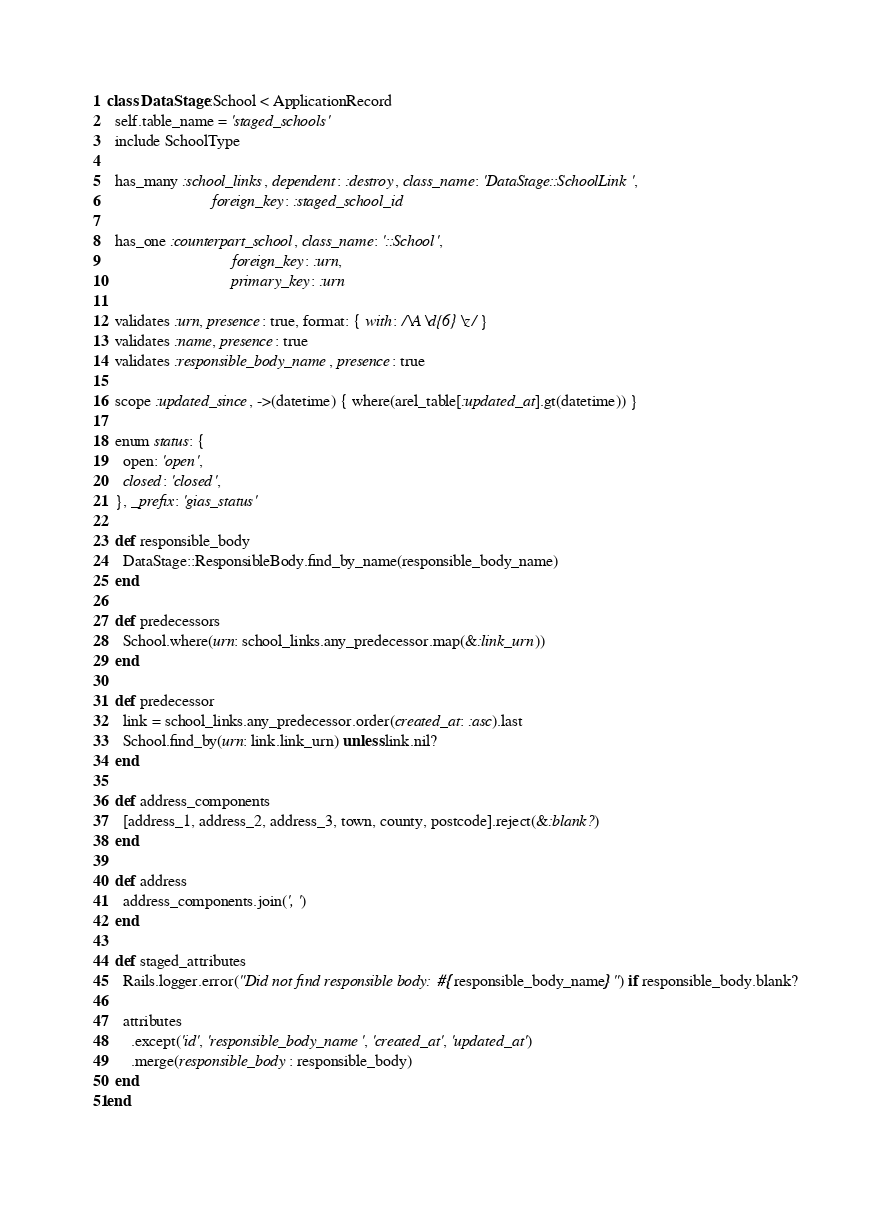<code> <loc_0><loc_0><loc_500><loc_500><_Ruby_>class DataStage::School < ApplicationRecord
  self.table_name = 'staged_schools'
  include SchoolType

  has_many :school_links, dependent: :destroy, class_name: 'DataStage::SchoolLink',
                          foreign_key: :staged_school_id

  has_one :counterpart_school, class_name: '::School',
                               foreign_key: :urn,
                               primary_key: :urn

  validates :urn, presence: true, format: { with: /\A\d{6}\z/ }
  validates :name, presence: true
  validates :responsible_body_name, presence: true

  scope :updated_since, ->(datetime) { where(arel_table[:updated_at].gt(datetime)) }

  enum status: {
    open: 'open',
    closed: 'closed',
  }, _prefix: 'gias_status'

  def responsible_body
    DataStage::ResponsibleBody.find_by_name(responsible_body_name)
  end

  def predecessors
    School.where(urn: school_links.any_predecessor.map(&:link_urn))
  end

  def predecessor
    link = school_links.any_predecessor.order(created_at: :asc).last
    School.find_by(urn: link.link_urn) unless link.nil?
  end

  def address_components
    [address_1, address_2, address_3, town, county, postcode].reject(&:blank?)
  end

  def address
    address_components.join(', ')
  end

  def staged_attributes
    Rails.logger.error("Did not find responsible body: #{responsible_body_name}") if responsible_body.blank?

    attributes
      .except('id', 'responsible_body_name', 'created_at', 'updated_at')
      .merge(responsible_body: responsible_body)
  end
end
</code> 